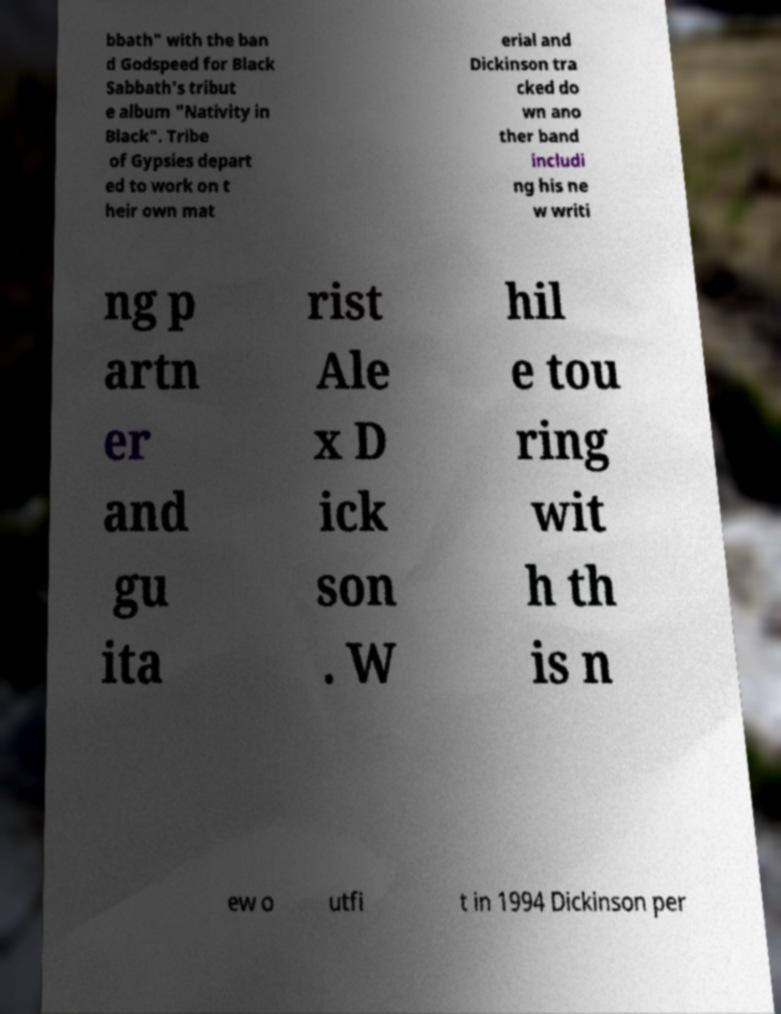There's text embedded in this image that I need extracted. Can you transcribe it verbatim? bbath" with the ban d Godspeed for Black Sabbath's tribut e album "Nativity in Black". Tribe of Gypsies depart ed to work on t heir own mat erial and Dickinson tra cked do wn ano ther band includi ng his ne w writi ng p artn er and gu ita rist Ale x D ick son . W hil e tou ring wit h th is n ew o utfi t in 1994 Dickinson per 